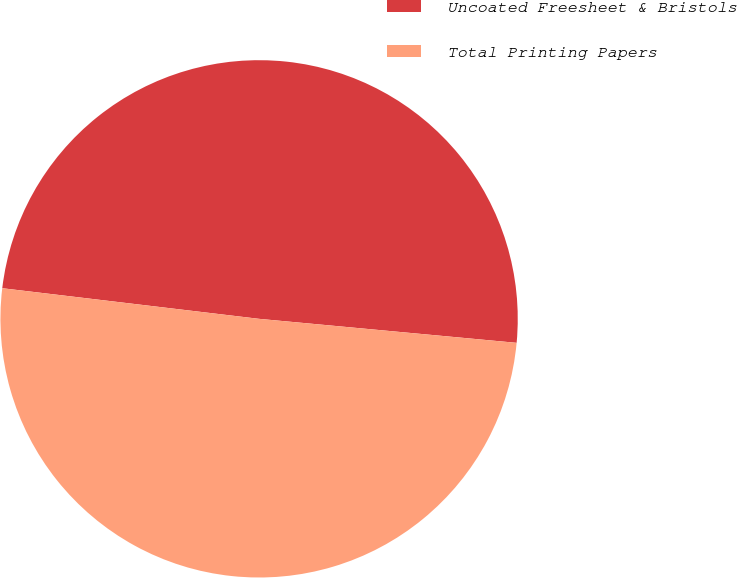Convert chart to OTSL. <chart><loc_0><loc_0><loc_500><loc_500><pie_chart><fcel>Uncoated Freesheet & Bristols<fcel>Total Printing Papers<nl><fcel>49.59%<fcel>50.41%<nl></chart> 